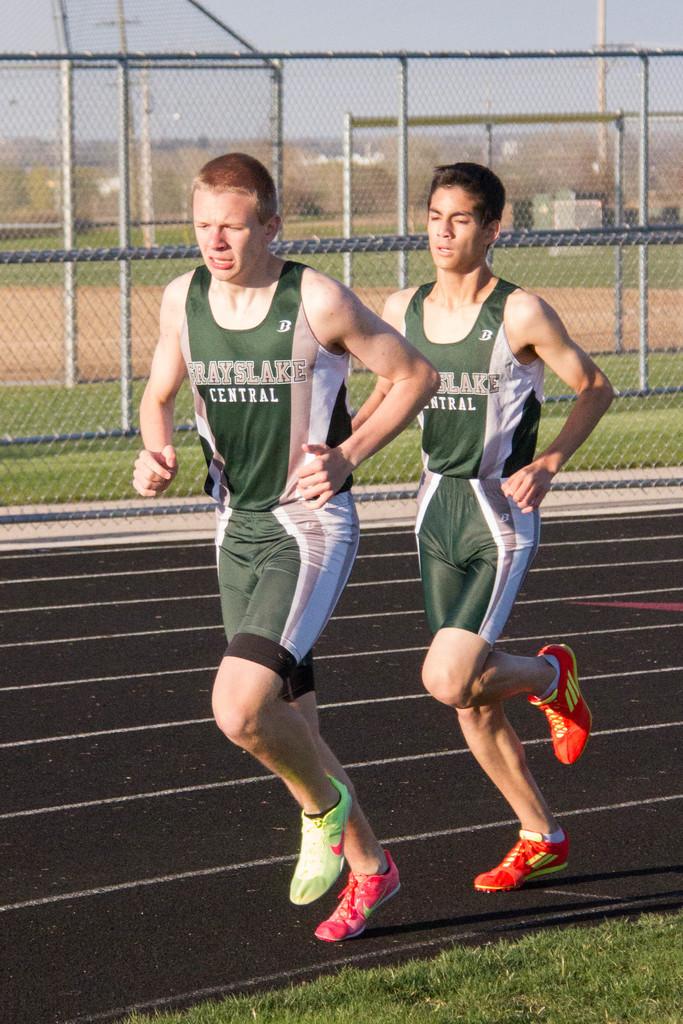Which school do the track stars attend?
Offer a terse response. Grayslake central. 